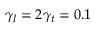Convert formula to latex. <formula><loc_0><loc_0><loc_500><loc_500>\gamma _ { l } = 2 \gamma _ { t } = 0 . 1</formula> 